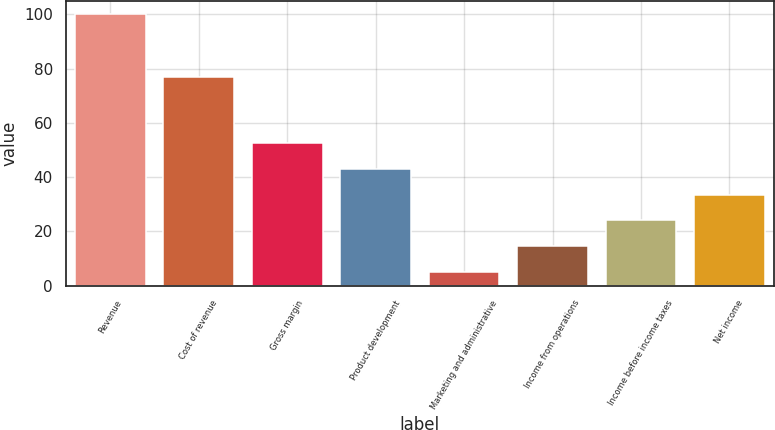Convert chart. <chart><loc_0><loc_0><loc_500><loc_500><bar_chart><fcel>Revenue<fcel>Cost of revenue<fcel>Gross margin<fcel>Product development<fcel>Marketing and administrative<fcel>Income from operations<fcel>Income before income taxes<fcel>Net income<nl><fcel>100<fcel>77<fcel>52.5<fcel>43<fcel>5<fcel>14.5<fcel>24<fcel>33.5<nl></chart> 